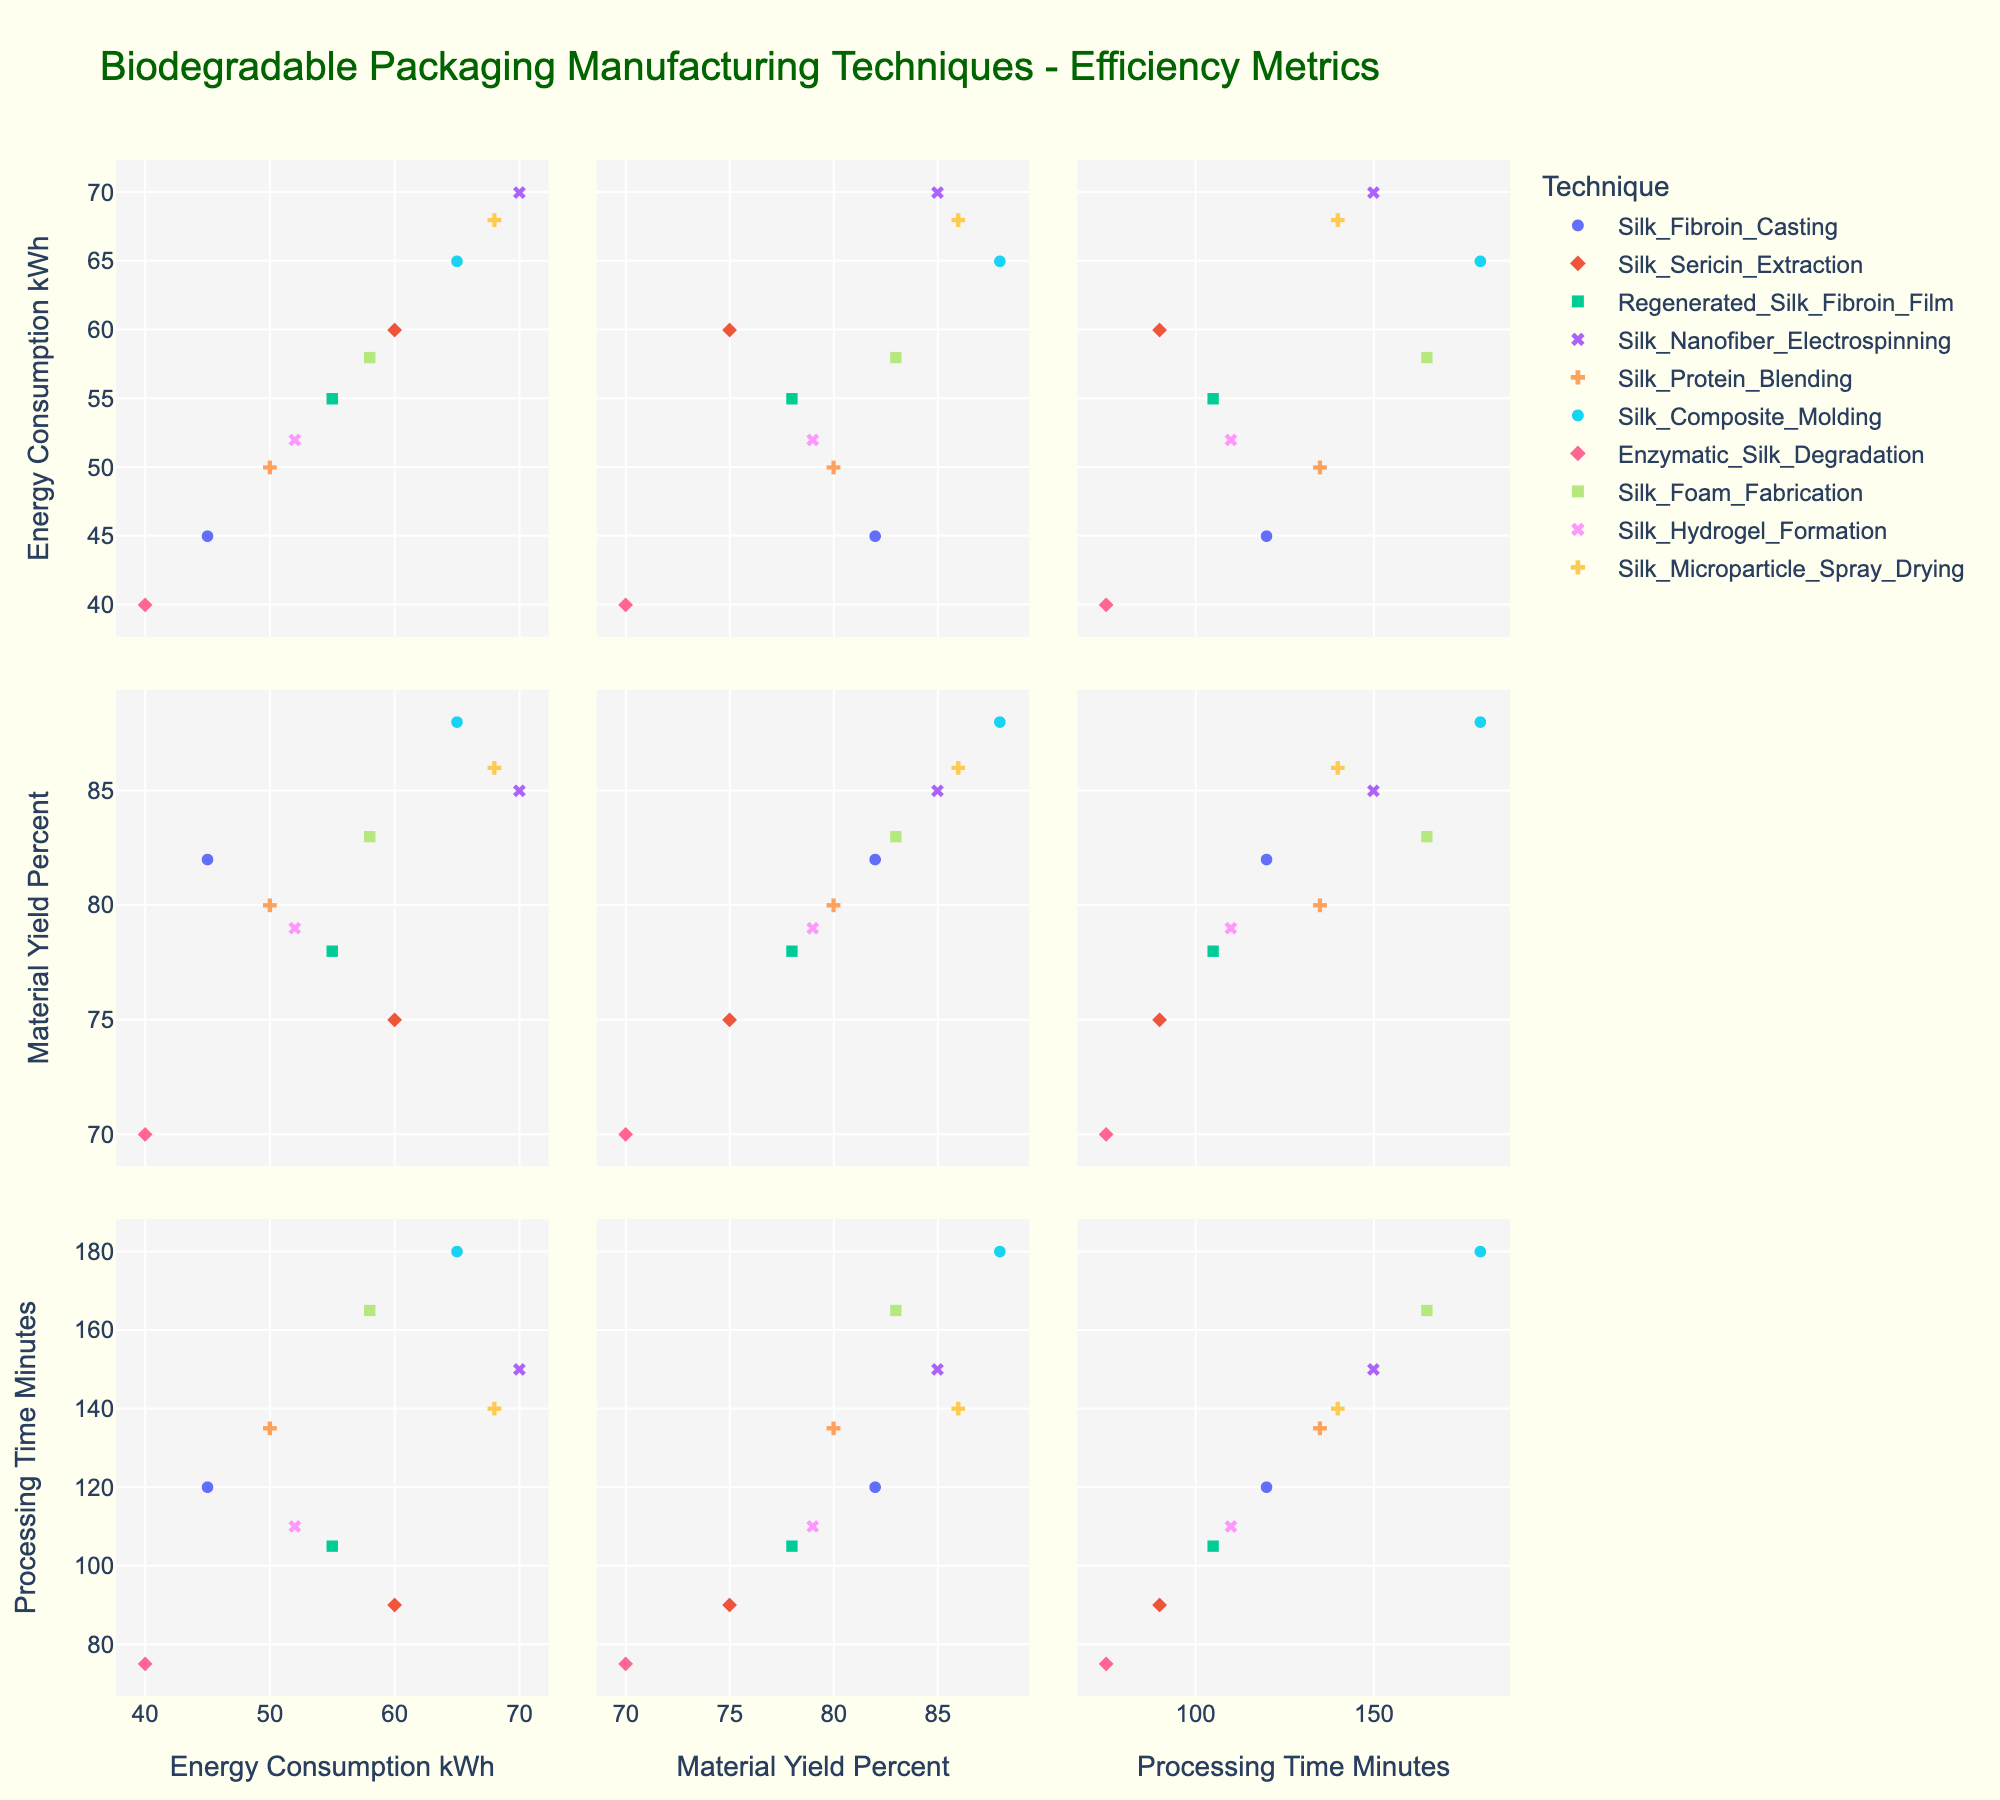What is the title of the figure? The title is typically found at the top center of the plot, visually separating it from the graph area.
Answer: Biodegradable Packaging Manufacturing Techniques - Efficiency Metrics Which technique has the highest material yield percentage? Looking at the 'Material Yield Percent' axis and finding the highest point, then identifying its corresponding technique symbol.
Answer: Silk Composite Molding How many data points correspond to the technique "Silk Foam Fabrication"? Each data point can be identified by the color and symbol specific to the technique mentioned in the legend. Count all respective points for "Silk Foam Fabrication".
Answer: One What is the range of energy consumption across all techniques? Find the minimum and maximum values on the 'Energy Consumption (kWh)' axis to determine the range.
Answer: 30 kWh (minimum) to 70 kWh (maximum) Which two techniques have the closest material yield percentages? Check the data points on the 'Material Yield Percent' axis for those that are nearest to each other and identify their corresponding techniques.
Answer: Silk Fibroin Casting and Silk Hydrogel Formation Does any technique have both the highest energy consumption and the highest material yield? Compare the techniques at the extreme ends of the 'Energy Consumption' and 'Material Yield Percent' axes to see if they match.
Answer: No Among the depicted techniques, which one has the longest processing time? Identify the highest point on the 'Processing Time (Minutes)' axis and match that point to the technique listed in the legend.
Answer: Silk Composite Molding Is there a visible trend between energy consumption and material yield? Observe the scatterplot matrix comparing 'Energy Consumption kWh' to 'Material Yield Percent' for any obvious pattern like positive correlation, negative correlation, or scattering.
Answer: No obvious trend Which technique has the shortest processing time and what is its material yield percentage? Find the shortest processing time point on the 'Processing Time (Minutes)' axis and trace horizontally to identify its material yield percentage from the 'Material Yield Percent' axis.
Answer: Enzymatic Silk Degradation, 70% Are there any techniques that show both high energy consumption and high processing time? Check for techniques that plot near the top-right corner in subplots comparing 'Energy Consumption' with 'Processing Time' for both high values.
Answer: Silk Composite Molding and Silk Nanofiber Electrospinning 